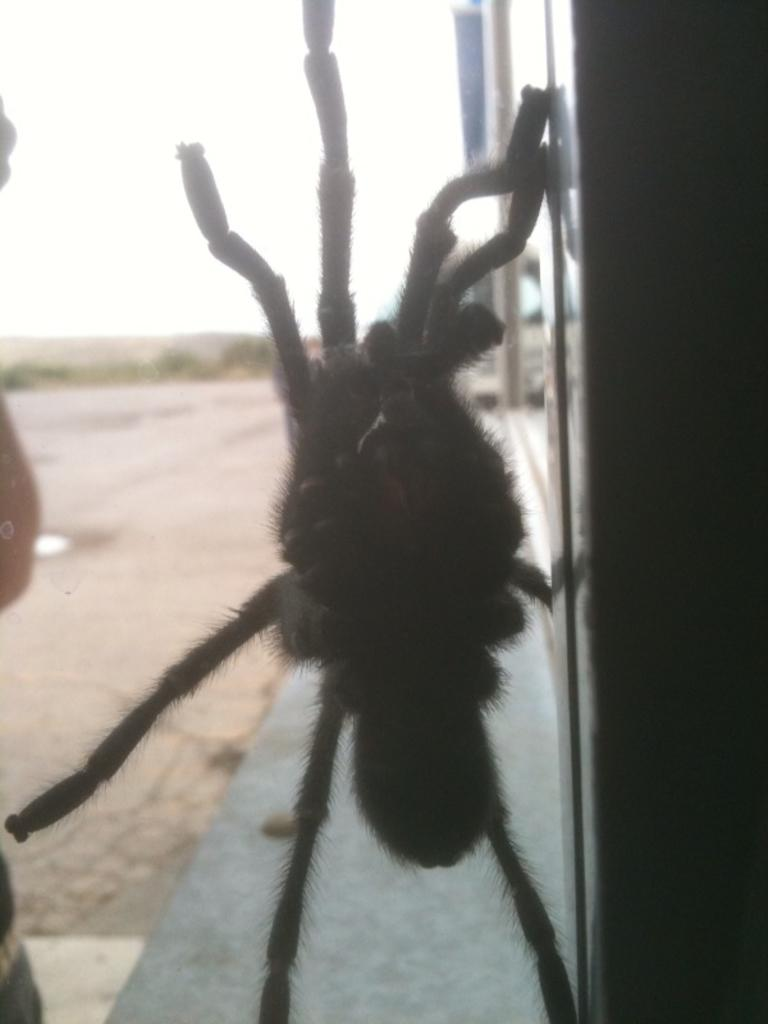What type of creature can be seen in the image? There is an insect in the image. What else is present in the image besides the insect? There is an object in the image. What can be seen in the background of the image? The ground and the sky are visible in the background of the image. What type of powder is being offered to the insect in the image? There is no powder or offering present in the image; it only features an insect and an object. 